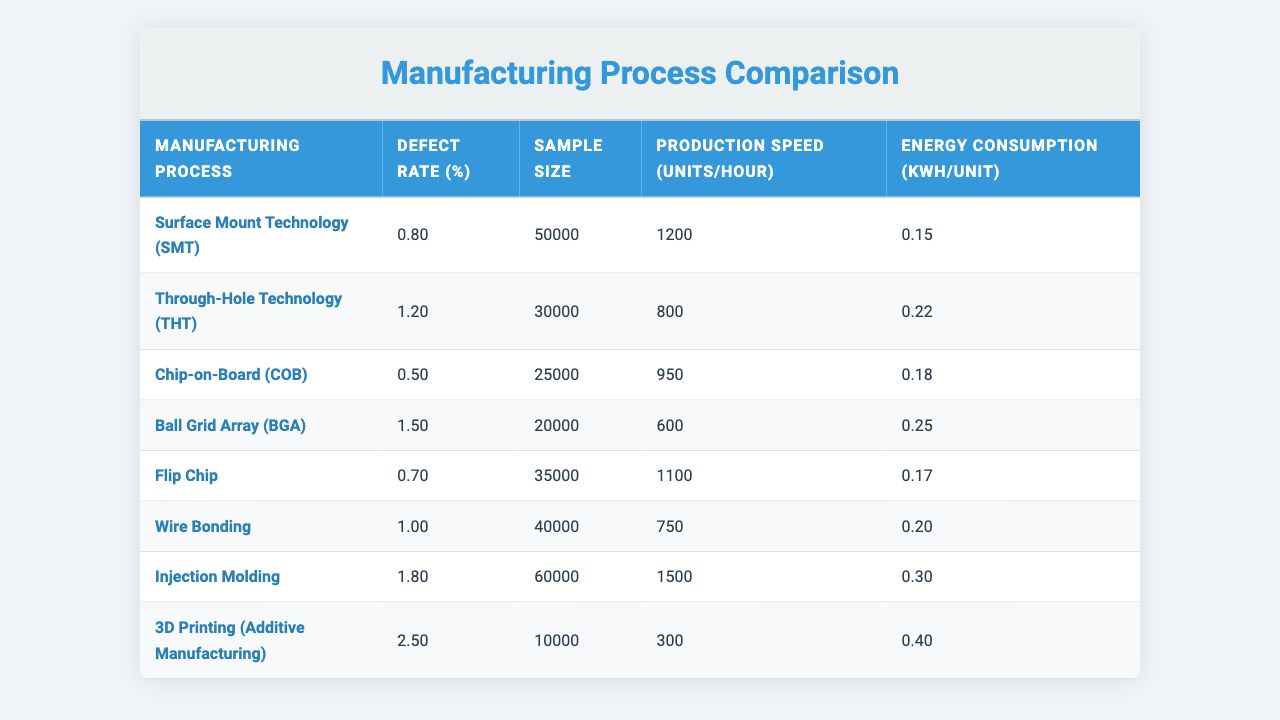What is the defect rate for Chip-on-Board (COB)? Looking at the table, the defect rate for Chip-on-Board (COB) is listed directly under the "Defect Rate (%)" column, which shows 0.5%
Answer: 0.5% Which manufacturing process has the highest defect rate? By inspecting the "Defect Rate (%)" column, the maximum value is found for 3D Printing (Additive Manufacturing) at 2.5%
Answer: 2.5% What is the sample size for Surface Mount Technology (SMT)? The sample size for Surface Mount Technology (SMT) can be found in the corresponding row under the "Sample Size" column, listed as 50,000
Answer: 50000 What is the average defect rate across all manufacturing processes? To find the average, we sum the defect rates (0.8 + 1.2 + 0.5 + 1.5 + 0.7 + 1.0 + 1.8 + 2.5 = 9.0) and divide by the number of processes (8), giving us 9.0/8 = 1.125%
Answer: 1.125% Is the defect rate for Injection Molding higher than the average defect rate? We previously calculated the average defect rate as 1.125%. The defect rate for Injection Molding is 1.8%, which is higher than the average. Thus, the answer is yes
Answer: Yes What manufacturing process has the lowest production speed? The production speed is detailed in the "Production Speed (units/hour)" column, and 3D Printing (Additive Manufacturing) has the lowest value at 300 units/hour
Answer: 300 How much higher is the defect rate of Ball Grid Array (BGA) than that of Flip Chip? The defect rate for Ball Grid Array (BGA) is 1.5% and for Flip Chip it's 0.7%. The difference is 1.5 - 0.7 = 0.8%, indicating BGA has a higher defect rate
Answer: 0.8% What is the energy consumption for Through-Hole Technology (THT)? The energy consumption for Through-Hole Technology (THT) can be found in the "Energy Consumption (kWh/unit)" column, listed as 0.22
Answer: 0.22 True or False: The defect rate for Wire Bonding is less than 1.0%. The defect rate for Wire Bonding is exactly 1.0%. Therefore, the statement is false since it is not less than 1.0%
Answer: False Which manufacturing process requires the most energy per unit? By reviewing the "Energy Consumption (kWh/unit)" column, Injection Molding has the highest energy consumption at 0.30 kWh/unit
Answer: 0.30 